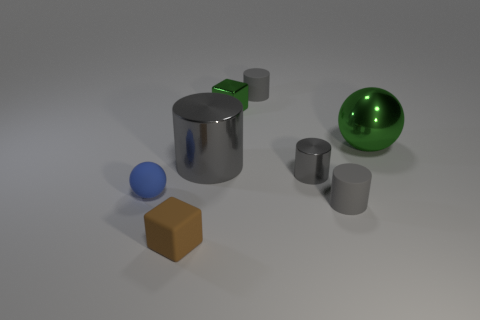Do the small block behind the tiny brown matte block and the brown object have the same material?
Your answer should be compact. No. Is the number of brown rubber objects behind the green ball less than the number of gray cylinders left of the small blue rubber thing?
Offer a very short reply. No. How many other things are the same material as the big green thing?
Give a very brief answer. 3. There is a green cube that is the same size as the brown cube; what material is it?
Keep it short and to the point. Metal. Is the number of small matte cylinders in front of the green shiny sphere less than the number of tiny blue cubes?
Offer a terse response. No. There is a small rubber object in front of the small matte cylinder that is in front of the ball that is right of the small brown object; what shape is it?
Provide a short and direct response. Cube. What is the size of the blue thing in front of the green sphere?
Your answer should be compact. Small. There is a gray shiny thing that is the same size as the blue matte thing; what is its shape?
Provide a short and direct response. Cylinder. How many objects are small shiny blocks or cubes on the right side of the brown thing?
Give a very brief answer. 1. What number of shiny objects are on the left side of the cylinder left of the tiny metal object that is behind the tiny shiny cylinder?
Provide a short and direct response. 0. 